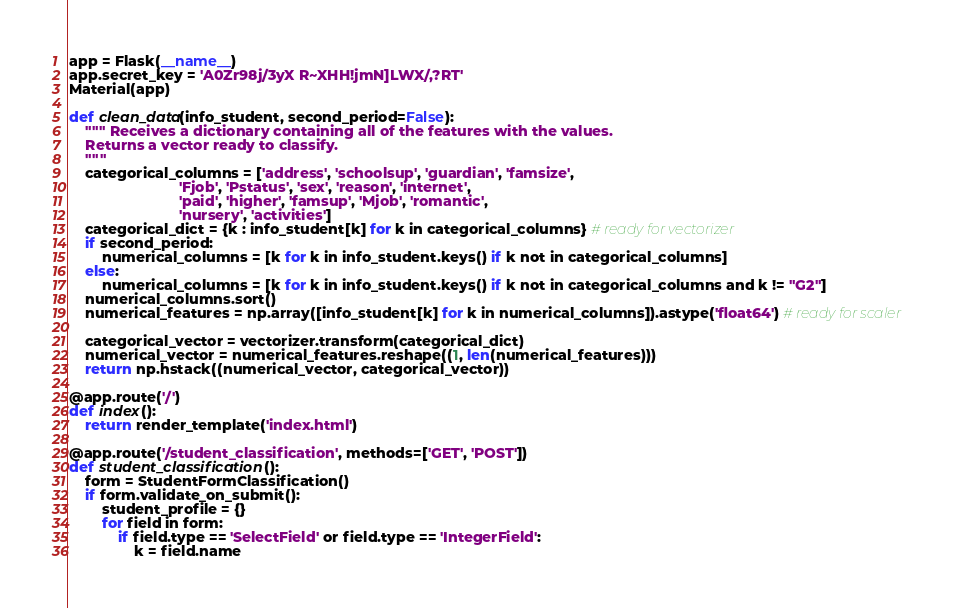Convert code to text. <code><loc_0><loc_0><loc_500><loc_500><_Python_>app = Flask(__name__)
app.secret_key = 'A0Zr98j/3yX R~XHH!jmN]LWX/,?RT'
Material(app)

def clean_data(info_student, second_period=False):
    """ Receives a dictionary containing all of the features with the values.
    Returns a vector ready to classify.
    """
    categorical_columns = ['address', 'schoolsup', 'guardian', 'famsize',
                           'Fjob', 'Pstatus', 'sex', 'reason', 'internet',
                           'paid', 'higher', 'famsup', 'Mjob', 'romantic',
                           'nursery', 'activities']
    categorical_dict = {k : info_student[k] for k in categorical_columns} # ready for vectorizer
    if second_period:
        numerical_columns = [k for k in info_student.keys() if k not in categorical_columns]
    else:
        numerical_columns = [k for k in info_student.keys() if k not in categorical_columns and k != "G2"]
    numerical_columns.sort()
    numerical_features = np.array([info_student[k] for k in numerical_columns]).astype('float64') # ready for scaler

    categorical_vector = vectorizer.transform(categorical_dict)
    numerical_vector = numerical_features.reshape((1, len(numerical_features)))
    return np.hstack((numerical_vector, categorical_vector))

@app.route('/')
def index():
    return render_template('index.html')

@app.route('/student_classification', methods=['GET', 'POST'])
def student_classification():
    form = StudentFormClassification()
    if form.validate_on_submit():
        student_profile = {}
        for field in form:
            if field.type == 'SelectField' or field.type == 'IntegerField':
                k = field.name</code> 